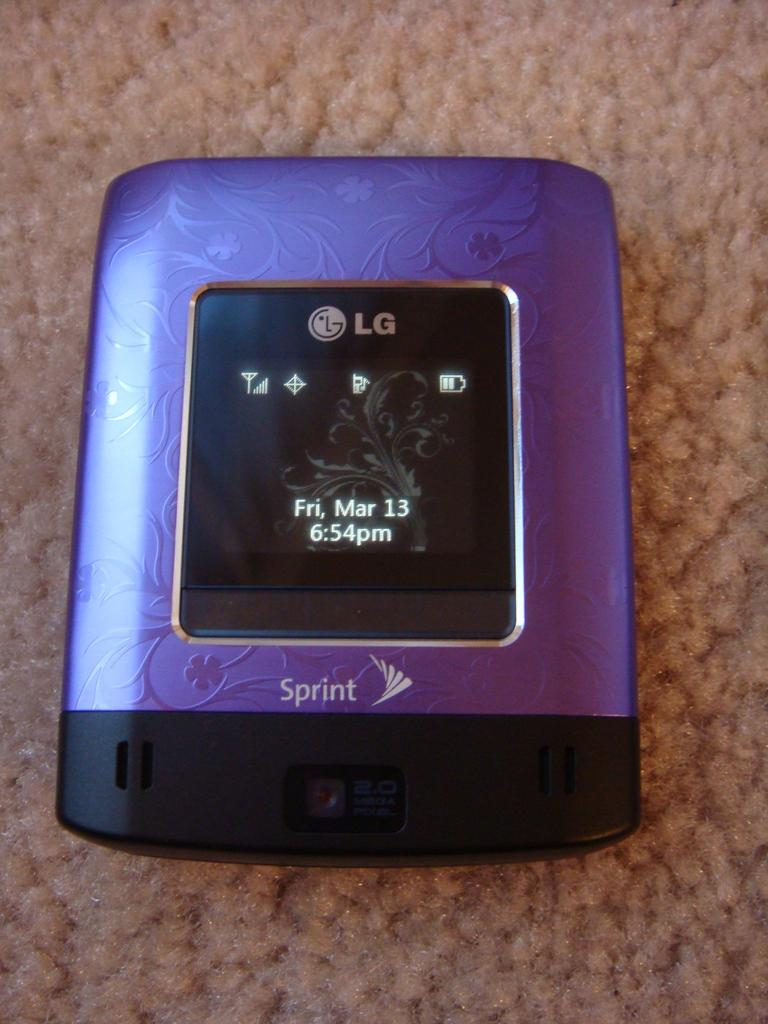Provide a one-sentence caption for the provided image. A purple Spring device made by LG with a display screen and 2 mega pixel camera on the bottom. 